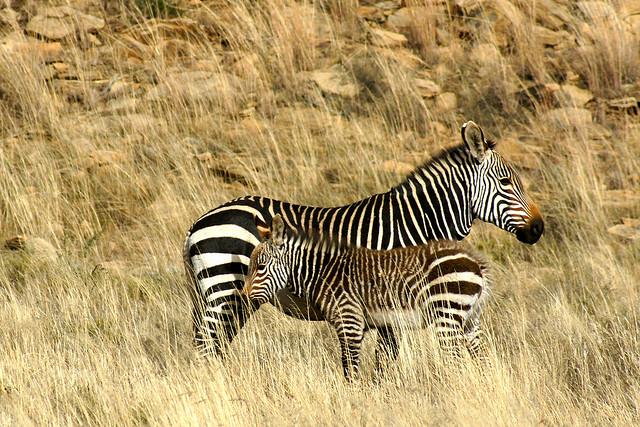Are these zebras mother and child?
Be succinct. Yes. Could this be in the wild?
Quick response, please. Yes. Is this in the wild?
Be succinct. Yes. 